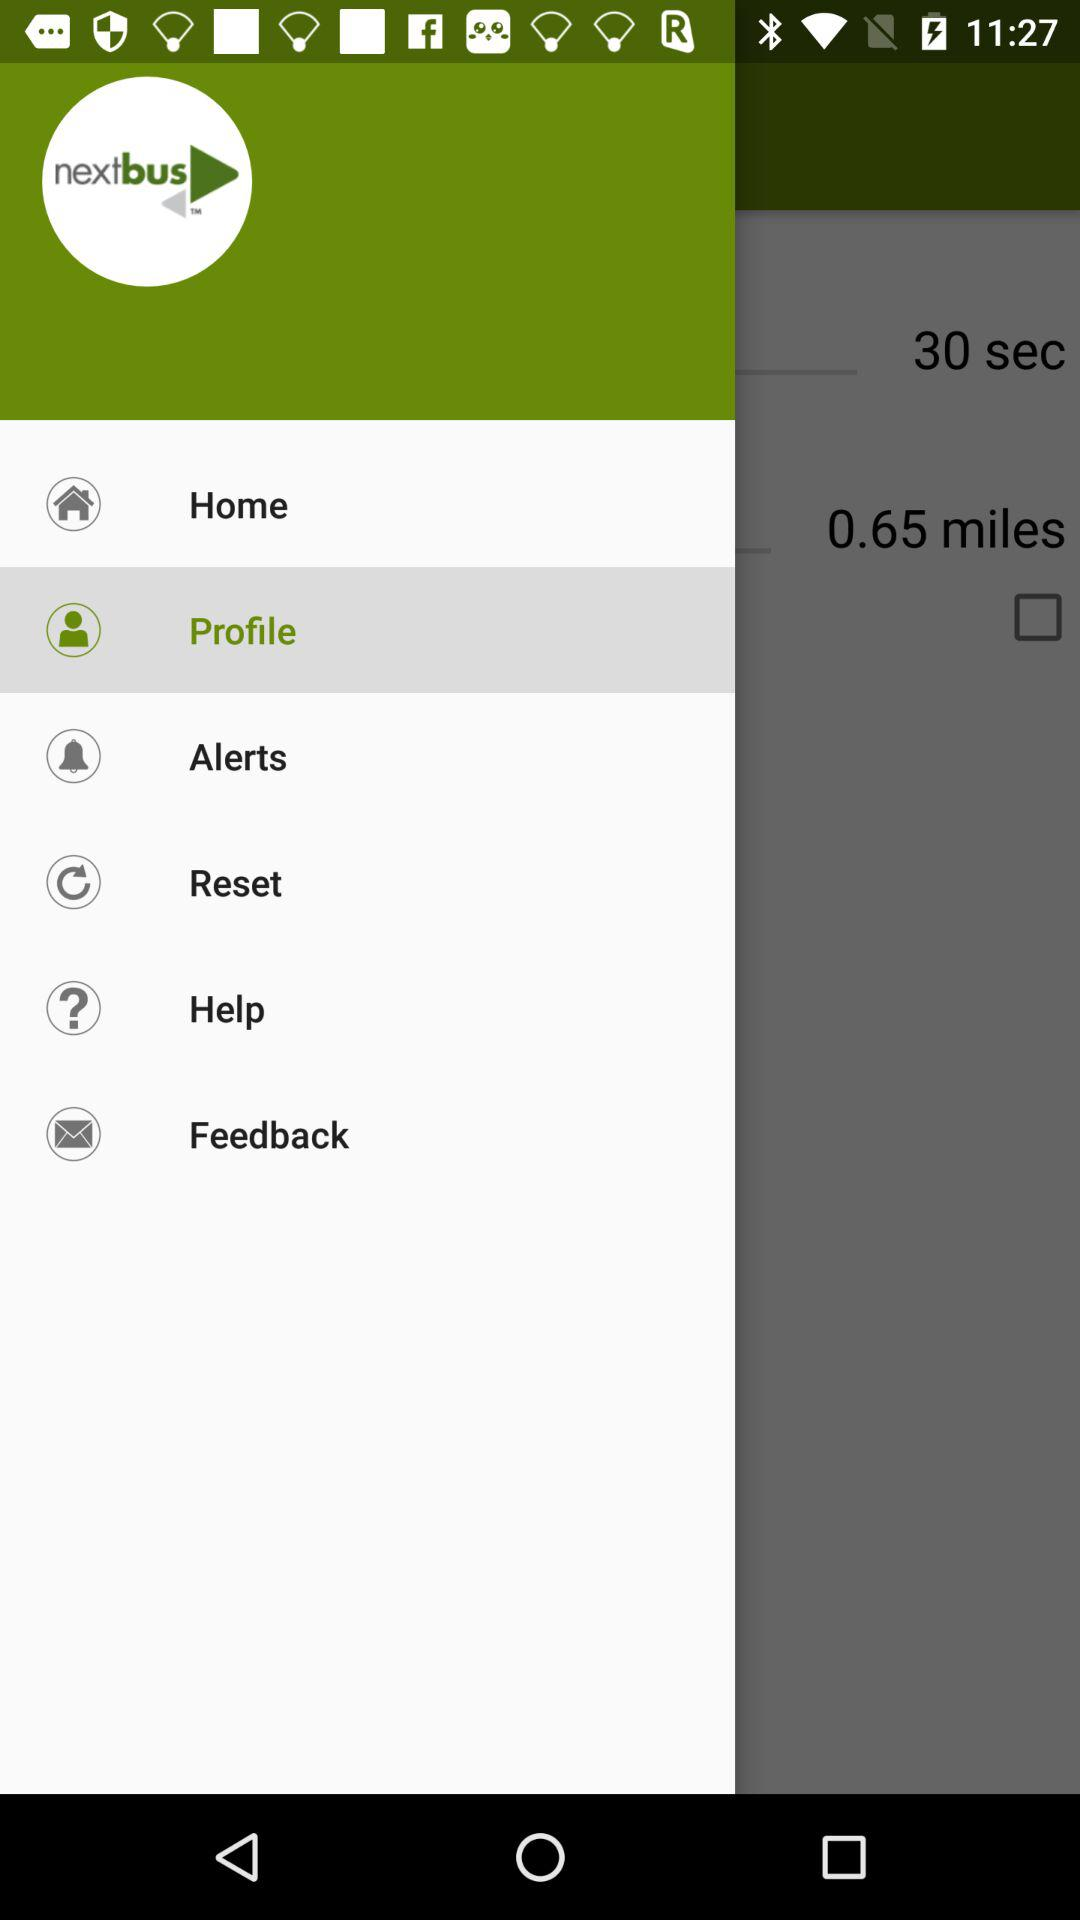What is the name of the application? The name of the application is "nextbus". 